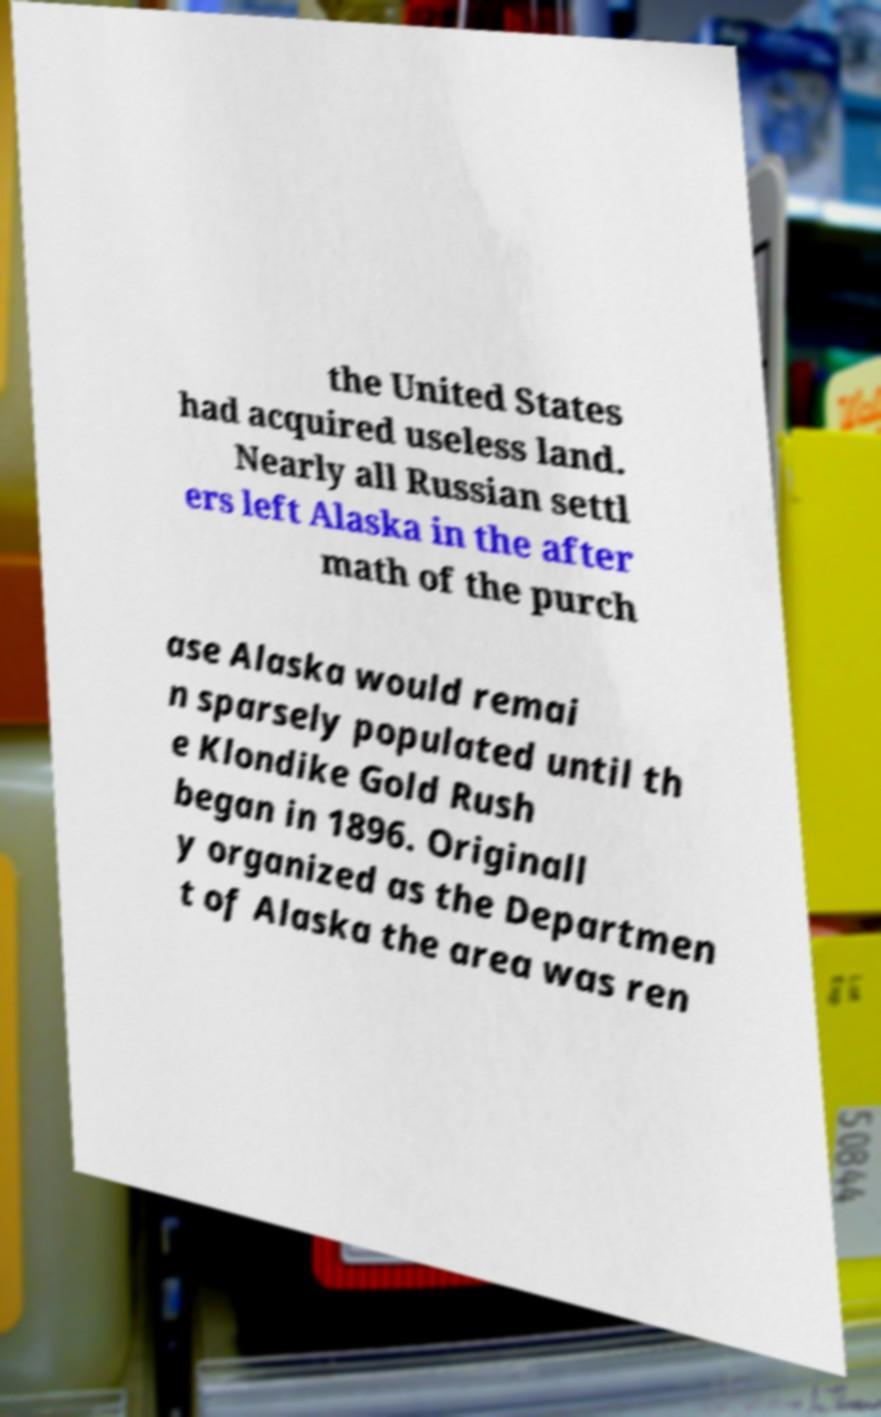I need the written content from this picture converted into text. Can you do that? the United States had acquired useless land. Nearly all Russian settl ers left Alaska in the after math of the purch ase Alaska would remai n sparsely populated until th e Klondike Gold Rush began in 1896. Originall y organized as the Departmen t of Alaska the area was ren 